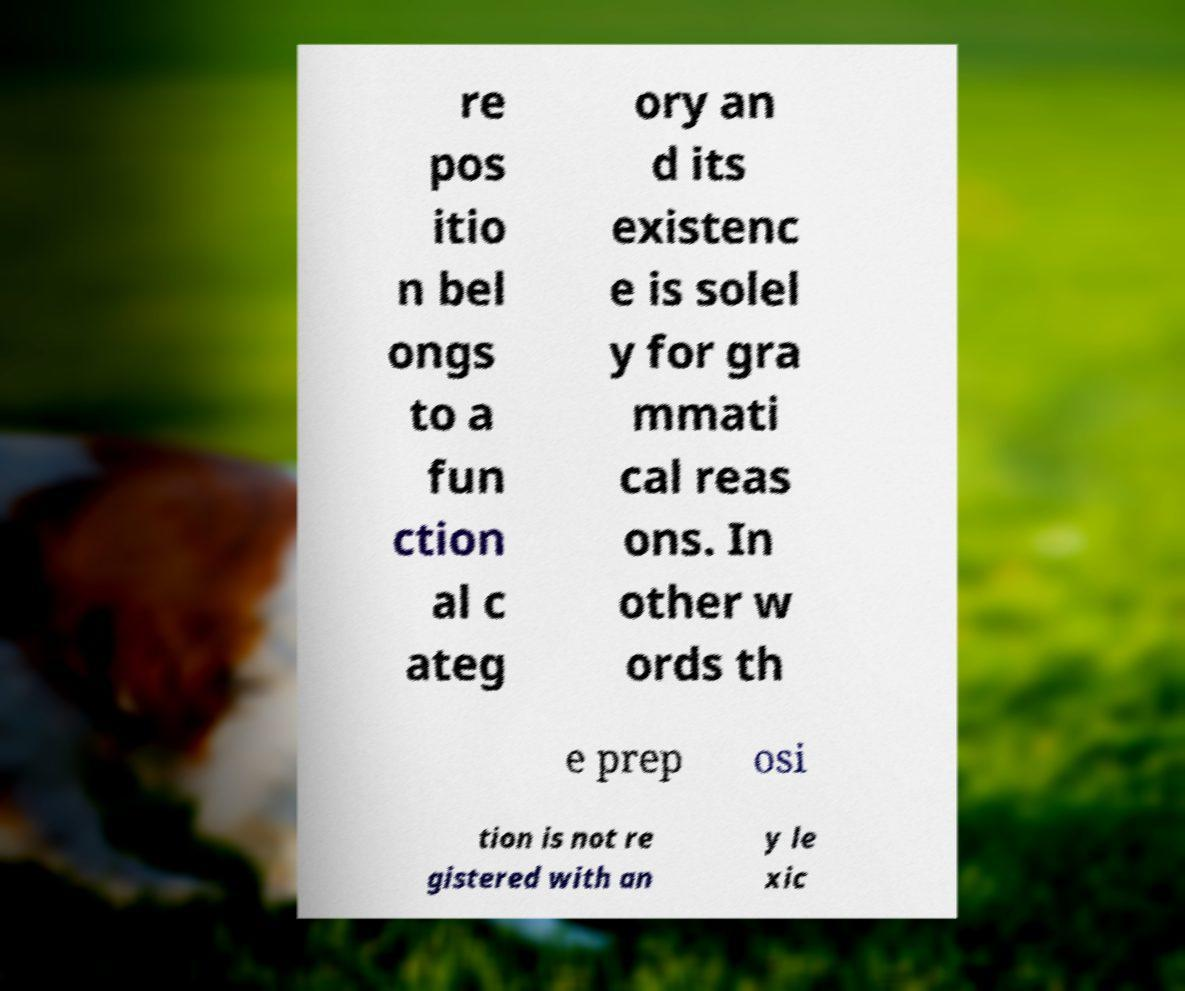Can you read and provide the text displayed in the image?This photo seems to have some interesting text. Can you extract and type it out for me? re pos itio n bel ongs to a fun ction al c ateg ory an d its existenc e is solel y for gra mmati cal reas ons. In other w ords th e prep osi tion is not re gistered with an y le xic 